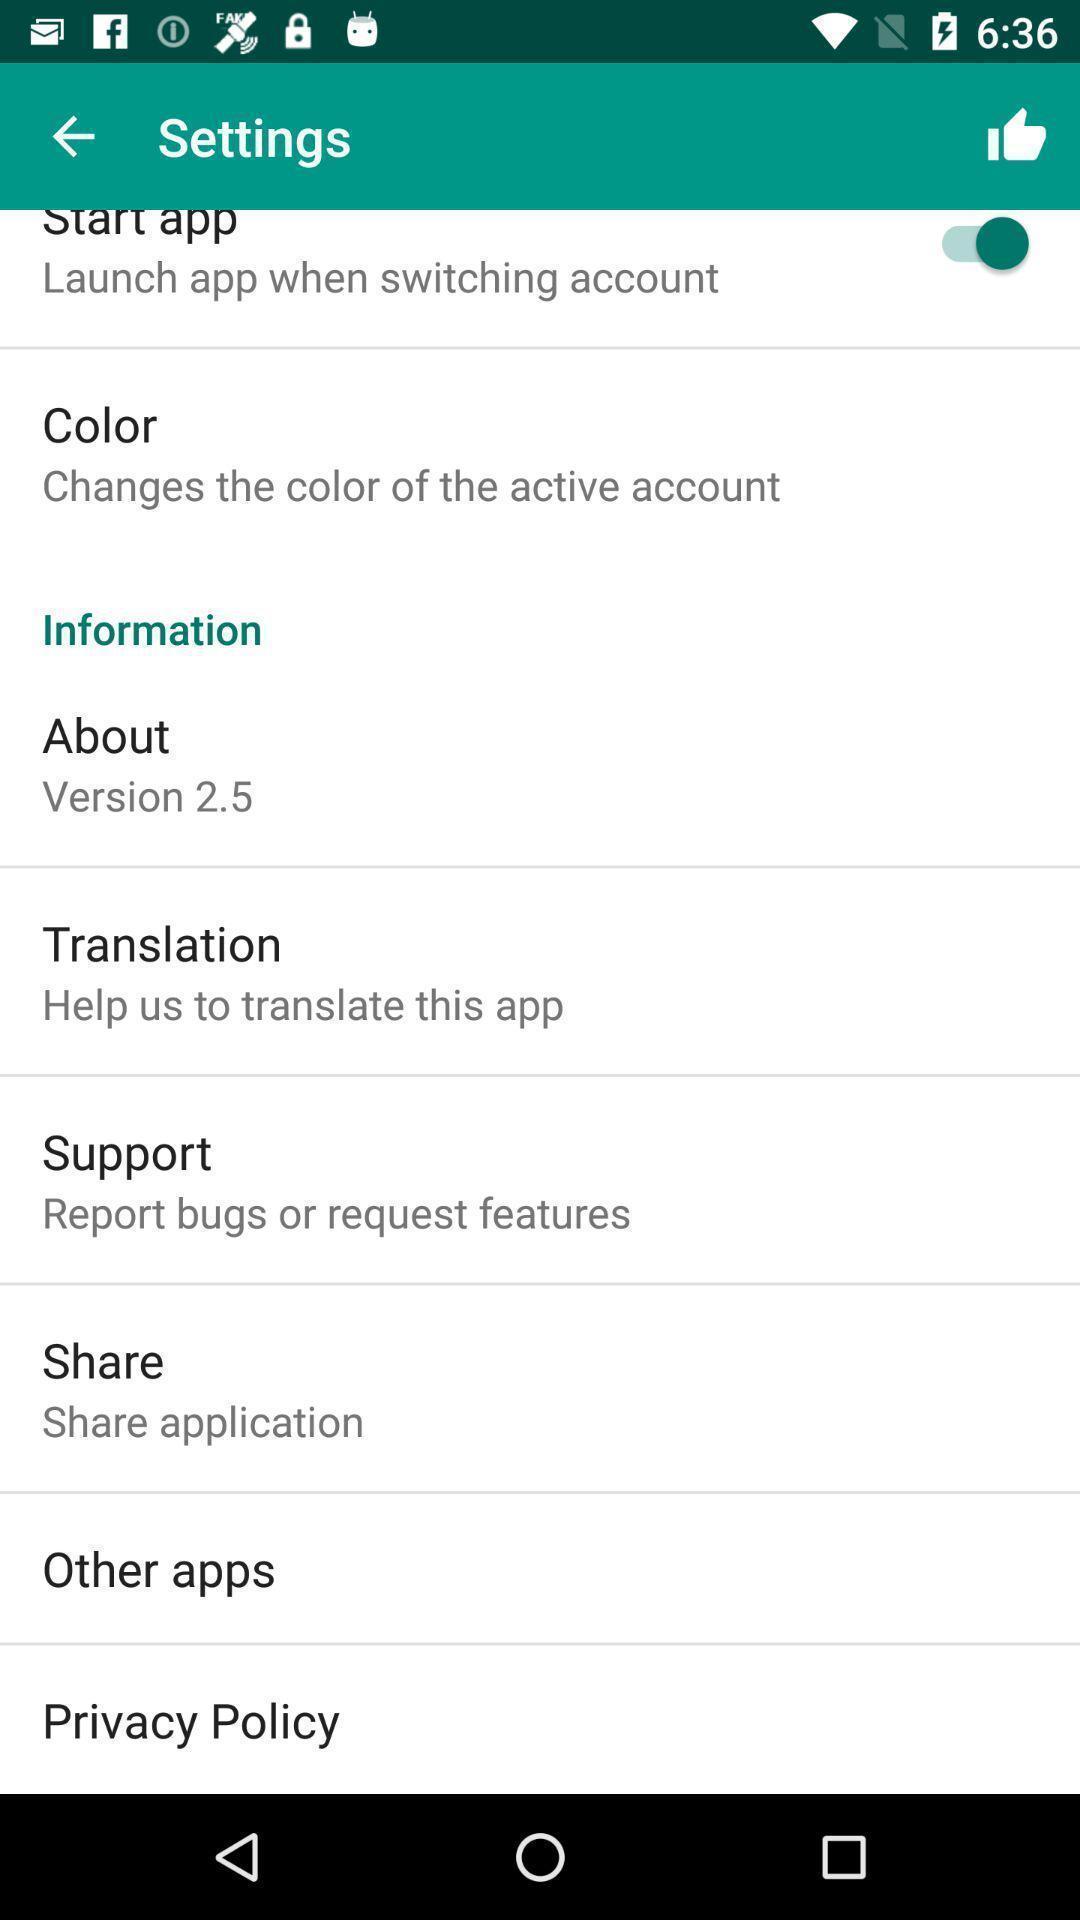Describe this image in words. Settings page with various options. 